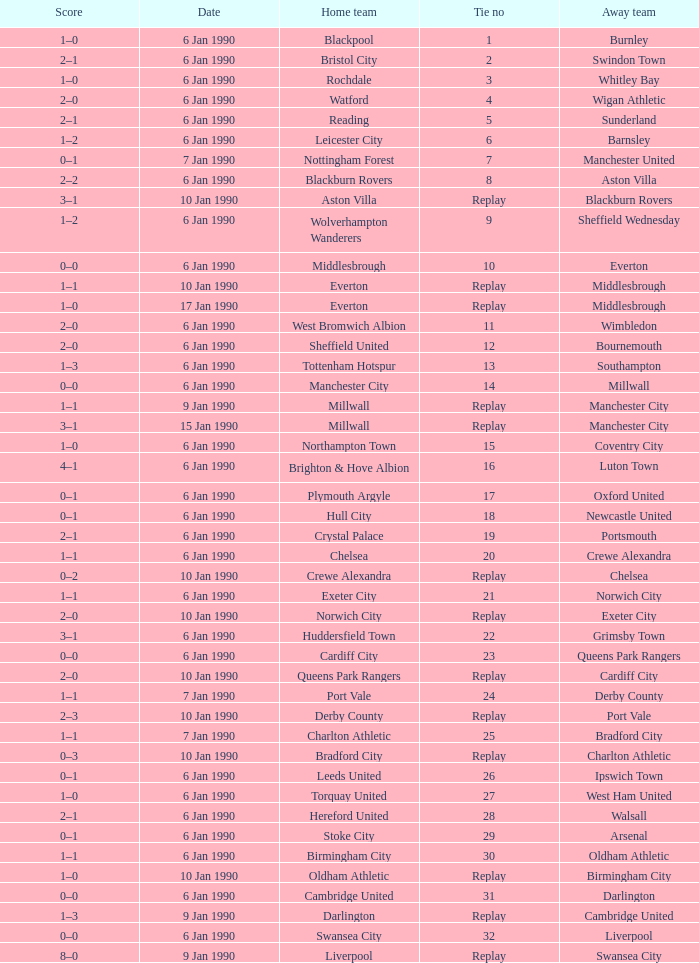What date did home team liverpool play? 9 Jan 1990. 